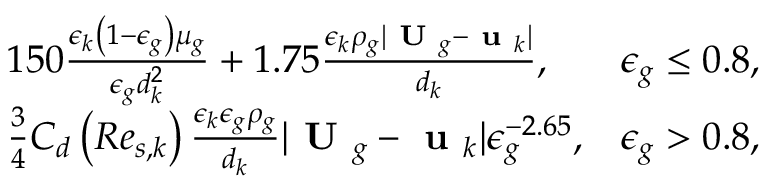<formula> <loc_0><loc_0><loc_500><loc_500>\begin{array} { r l r } & { 1 5 0 \frac { \epsilon _ { k } \left ( 1 - \epsilon _ { g } \right ) \mu _ { g } } { \epsilon _ { g } d _ { k } ^ { 2 } } + 1 . 7 5 \frac { \epsilon _ { k } \rho _ { g } | U _ { g } - u _ { k } | } { d _ { k } } , } & { \epsilon _ { g } \leq 0 . 8 , } \\ & { \frac { 3 } { 4 } C _ { d } \left ( R e _ { s , k } \right ) \frac { \epsilon _ { k } \epsilon _ { g } \rho _ { g } } { d _ { k } } | U _ { g } - u _ { k } | \epsilon _ { g } ^ { - 2 . 6 5 } , } & { \epsilon _ { g } > 0 . 8 , } \end{array}</formula> 